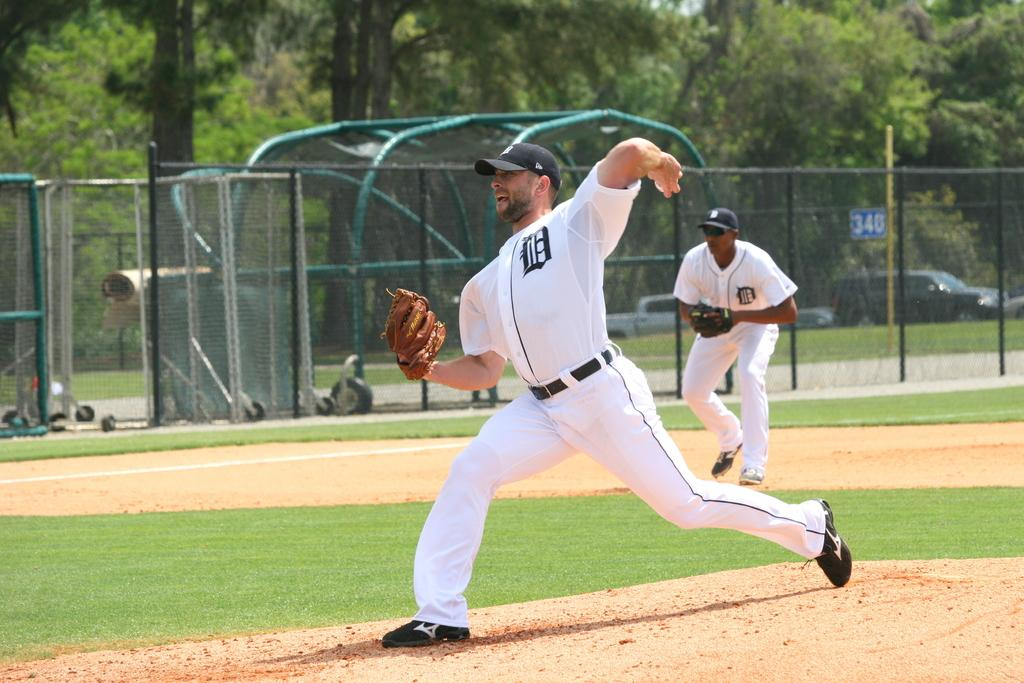How many people are present in the image? There are two men in the image. What are the men doing in the image? The men are playing on the ground. What color are the men's clothes in the image? The men are wearing white color dress. What protective gear are the men wearing? The men are wearing gloves. What can be seen in the background of the image? There is fencing, cars, and trees in the background of the image. How many pizzas are being served on the table in the image? There is no table or pizzas present in the image. What type of stem can be seen growing from the ground in the image? There is no stem growing from the ground in the image. 